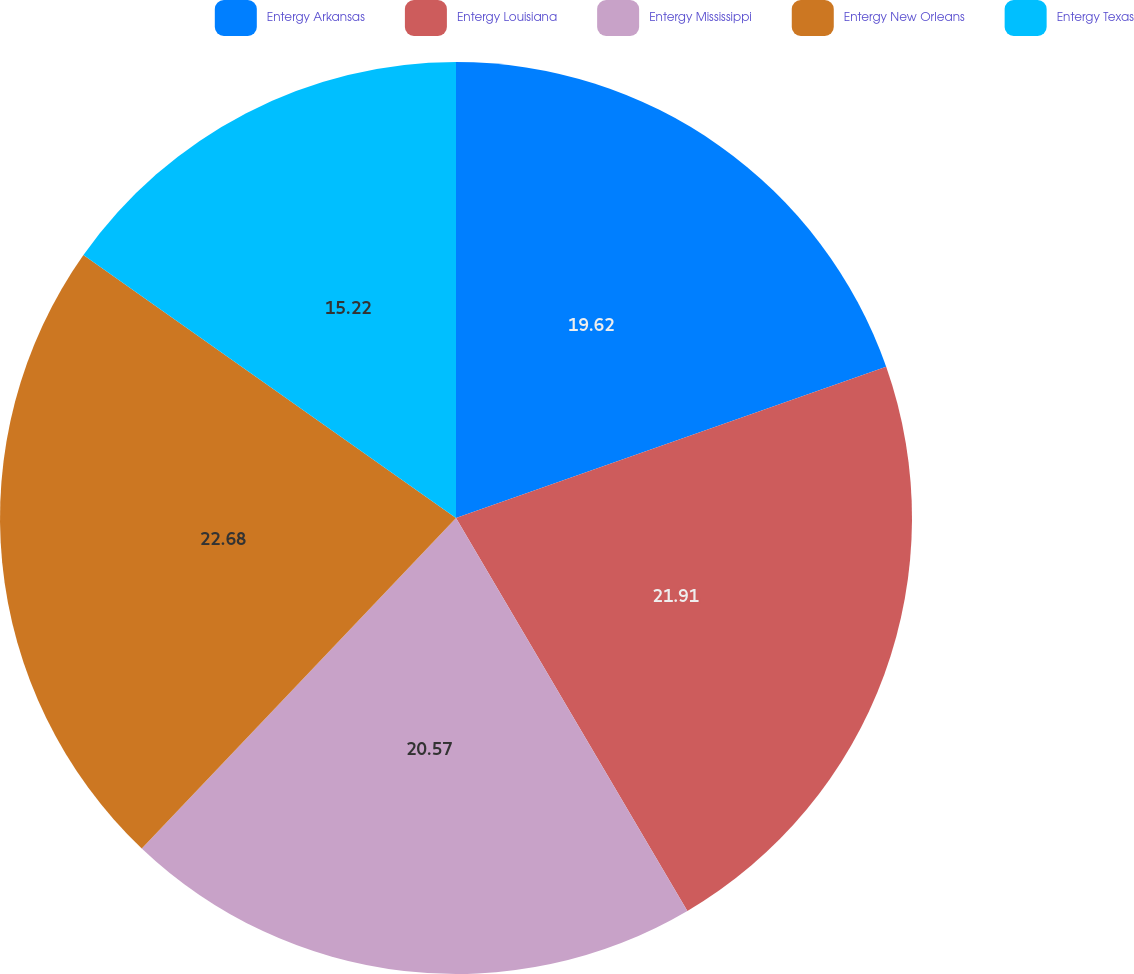Convert chart to OTSL. <chart><loc_0><loc_0><loc_500><loc_500><pie_chart><fcel>Entergy Arkansas<fcel>Entergy Louisiana<fcel>Entergy Mississippi<fcel>Entergy New Orleans<fcel>Entergy Texas<nl><fcel>19.62%<fcel>21.91%<fcel>20.57%<fcel>22.68%<fcel>15.22%<nl></chart> 